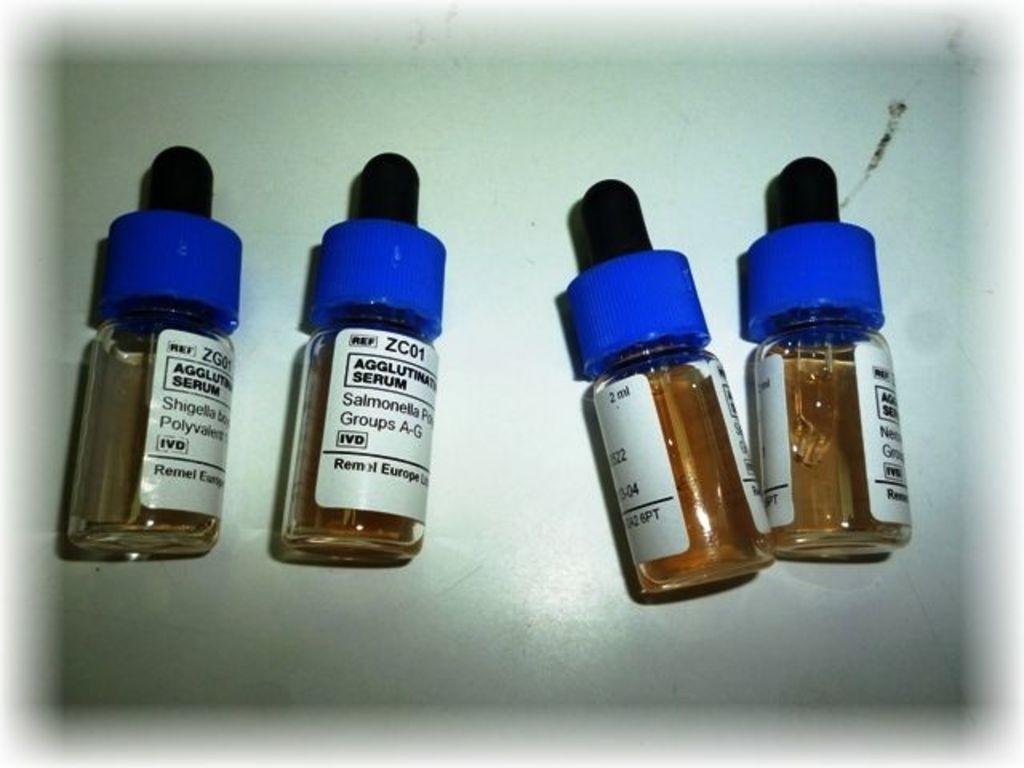Could you give a brief overview of what you see in this image? As we can see in the image there are four bottles. On the top of the bottle it's like a dropper. 